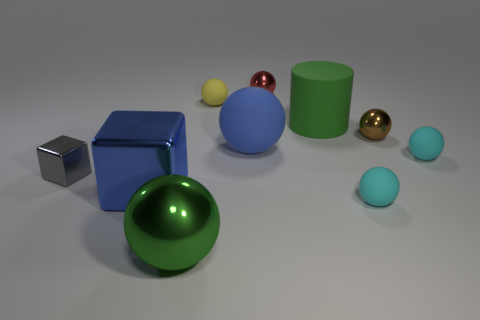Is there a yellow matte cube that has the same size as the blue ball?
Ensure brevity in your answer.  No. What is the shape of the tiny yellow object?
Your answer should be very brief. Sphere. Is the number of green objects that are on the left side of the tiny gray shiny thing greater than the number of shiny things left of the big cylinder?
Make the answer very short. No. Does the small matte object behind the big blue sphere have the same color as the big sphere that is right of the green sphere?
Offer a very short reply. No. The brown object that is the same size as the red thing is what shape?
Keep it short and to the point. Sphere. Are there any tiny gray objects of the same shape as the red metal object?
Provide a short and direct response. No. Is the material of the tiny gray thing left of the green cylinder the same as the large green object in front of the green matte thing?
Give a very brief answer. Yes. There is a object that is the same color as the matte cylinder; what shape is it?
Offer a very short reply. Sphere. How many other big spheres have the same material as the red ball?
Keep it short and to the point. 1. The cylinder has what color?
Provide a succinct answer. Green. 